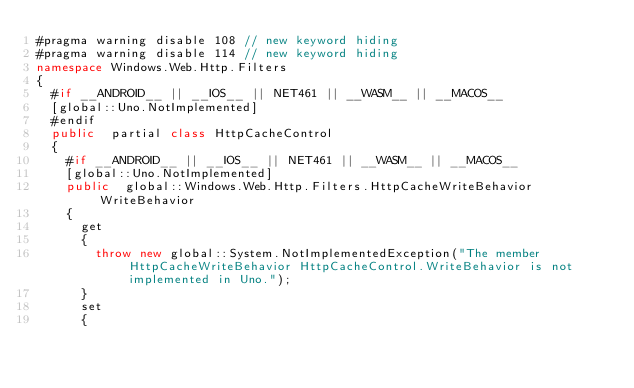Convert code to text. <code><loc_0><loc_0><loc_500><loc_500><_C#_>#pragma warning disable 108 // new keyword hiding
#pragma warning disable 114 // new keyword hiding
namespace Windows.Web.Http.Filters
{
	#if __ANDROID__ || __IOS__ || NET461 || __WASM__ || __MACOS__
	[global::Uno.NotImplemented]
	#endif
	public  partial class HttpCacheControl 
	{
		#if __ANDROID__ || __IOS__ || NET461 || __WASM__ || __MACOS__
		[global::Uno.NotImplemented]
		public  global::Windows.Web.Http.Filters.HttpCacheWriteBehavior WriteBehavior
		{
			get
			{
				throw new global::System.NotImplementedException("The member HttpCacheWriteBehavior HttpCacheControl.WriteBehavior is not implemented in Uno.");
			}
			set
			{</code> 